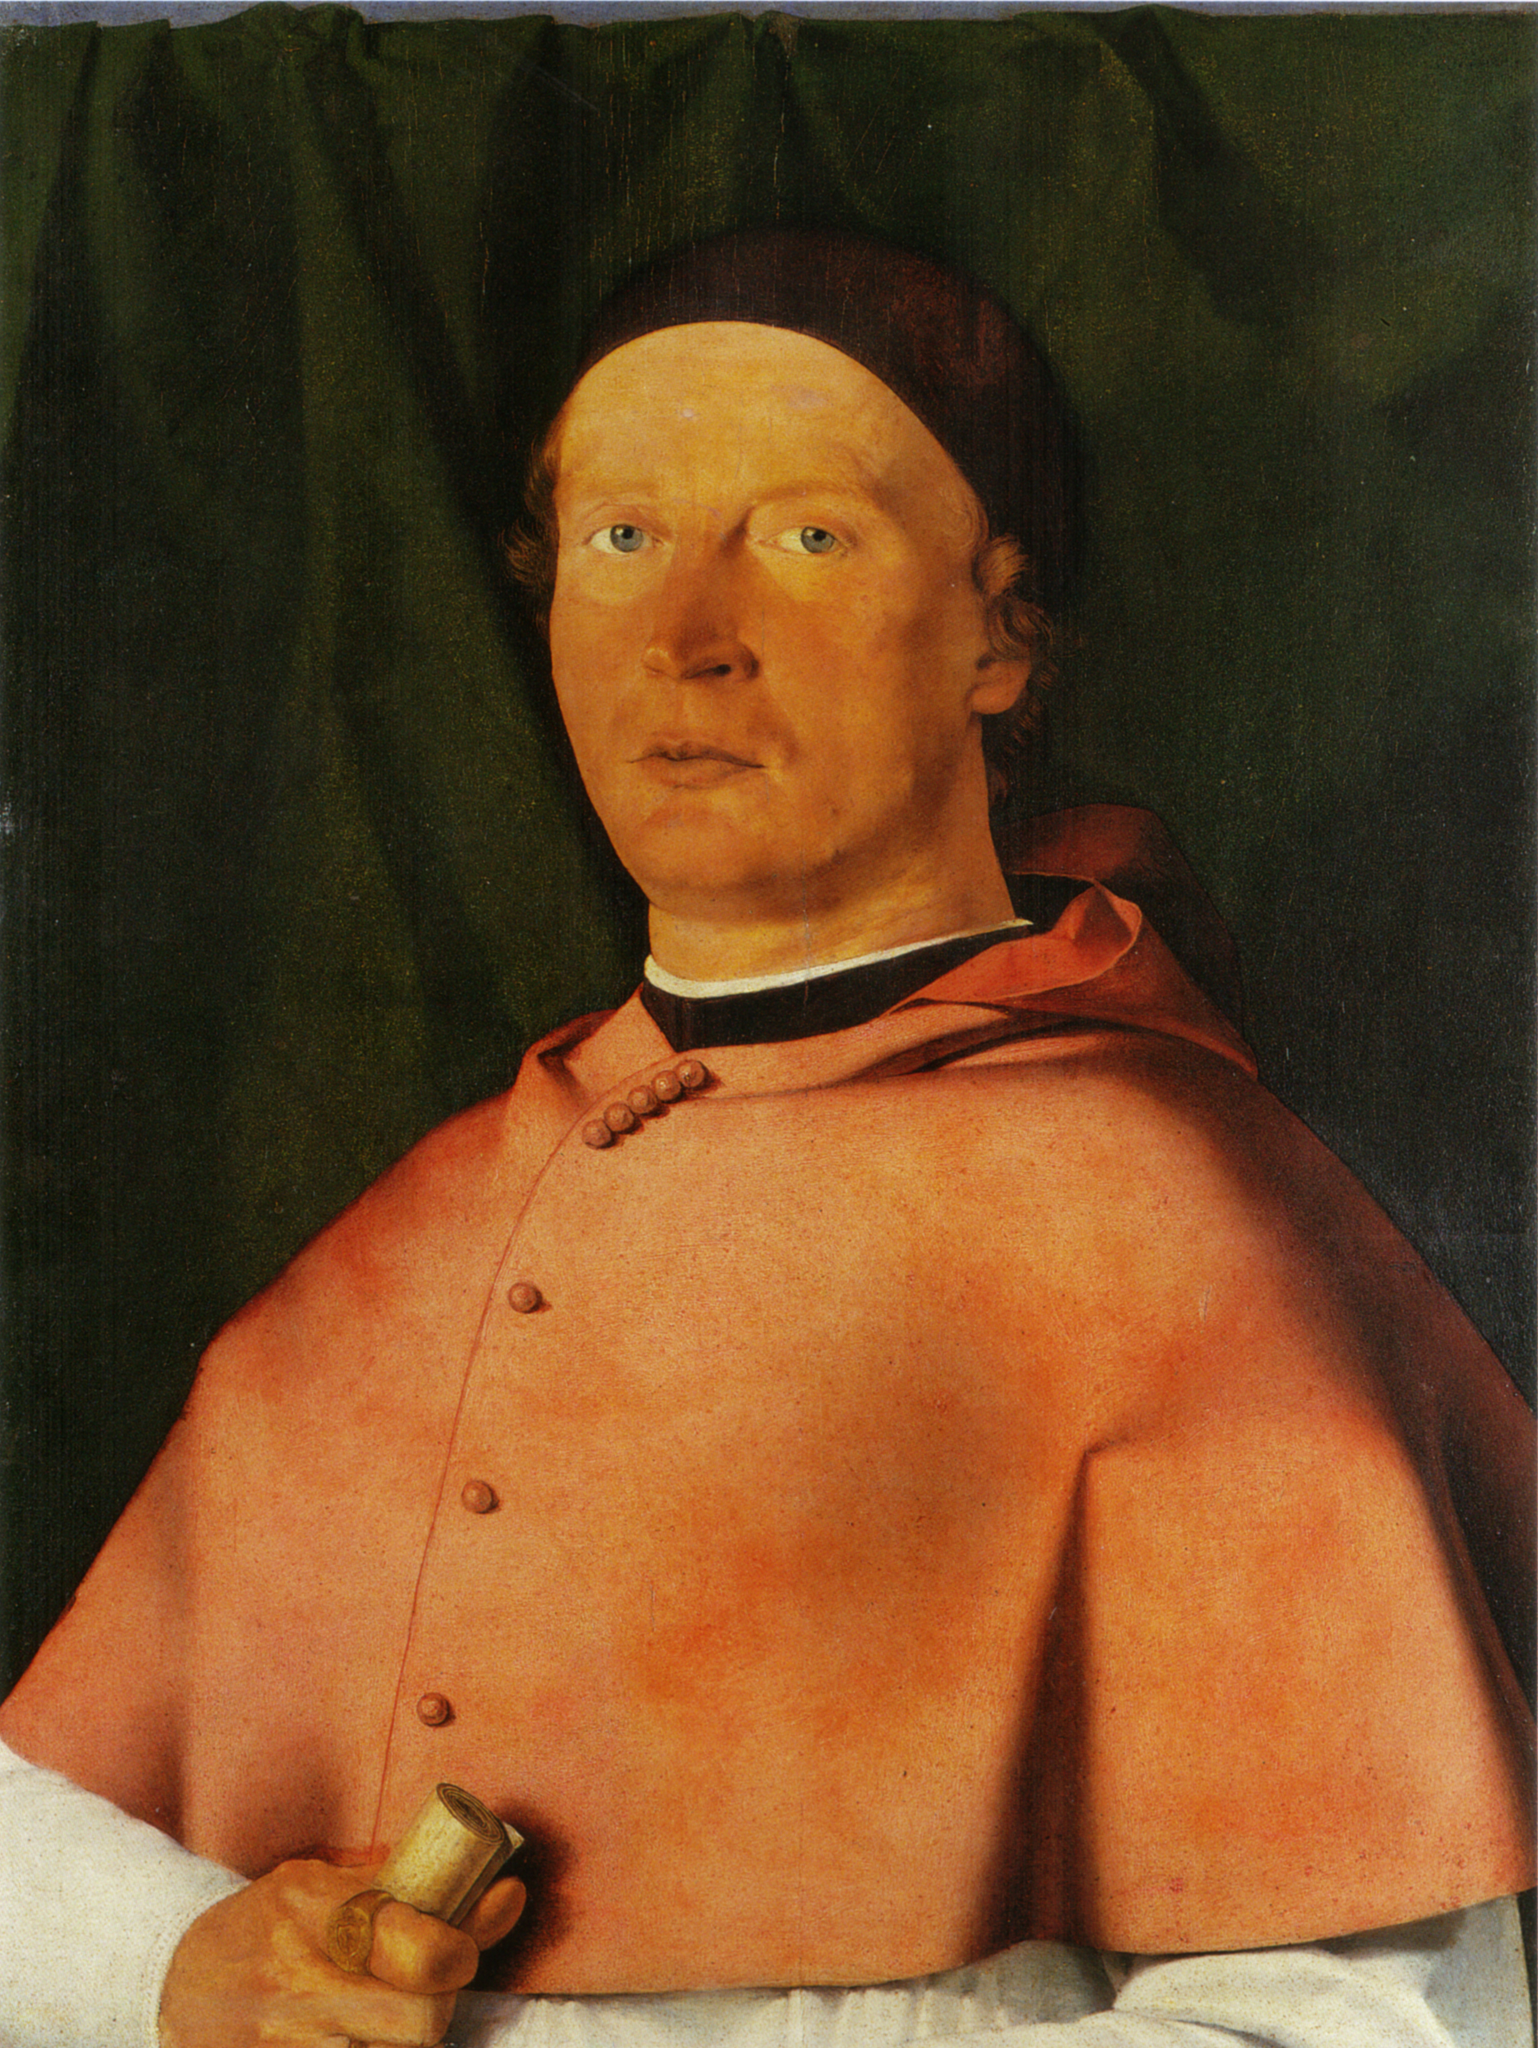How does the artist's use of color contribute to the mood of the painting? The artist's thoughtful use of color plays a pivotal role in the painting's emotive ambiance. The rich red hue of the robe draws immediate attention, imbuing the portrait with a sense of importance and vigor. In contrast, the muted green of the curtain serves as a calming backdrop that throws the vibrant red into even sharper relief. The starkness of the green also evokes a solemn, almost austere atmosphere, subtly shaping our emotional response to the subject. The colors chosen are not only indicative of the status of the individual but also contribute to a narrative that is both stately and introspective. 